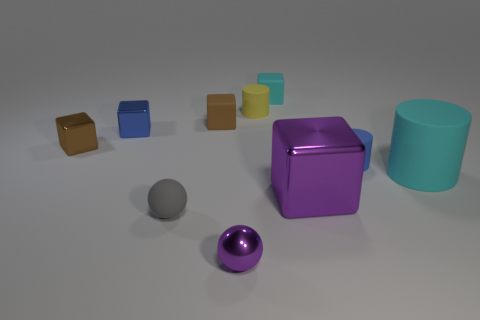Can you compare the sizes of the different colored cubes in the image? Certainly, the cubes present a variety of sizes. The brown and blue cubes are the smallest, followed by the yellow and teal cubes which are slightly larger. The largest is the purple cube, which has a more prominent position in the image. 